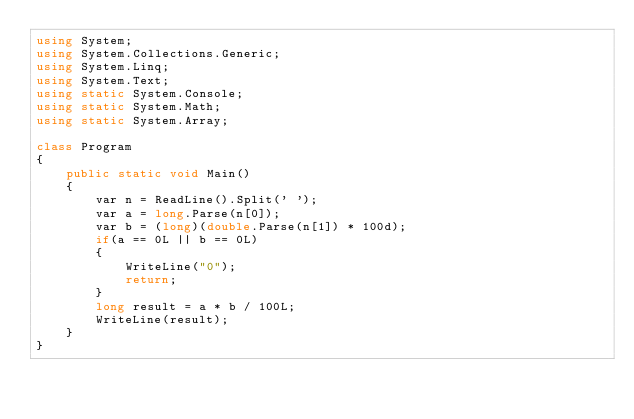<code> <loc_0><loc_0><loc_500><loc_500><_C#_>using System;
using System.Collections.Generic;
using System.Linq;
using System.Text;
using static System.Console;
using static System.Math;
using static System.Array;

class Program
{
    public static void Main()
    {
        var n = ReadLine().Split(' ');
        var a = long.Parse(n[0]);
        var b = (long)(double.Parse(n[1]) * 100d);
        if(a == 0L || b == 0L)
        {
            WriteLine("0");
            return;
        }
        long result = a * b / 100L;
        WriteLine(result);
    }
}</code> 